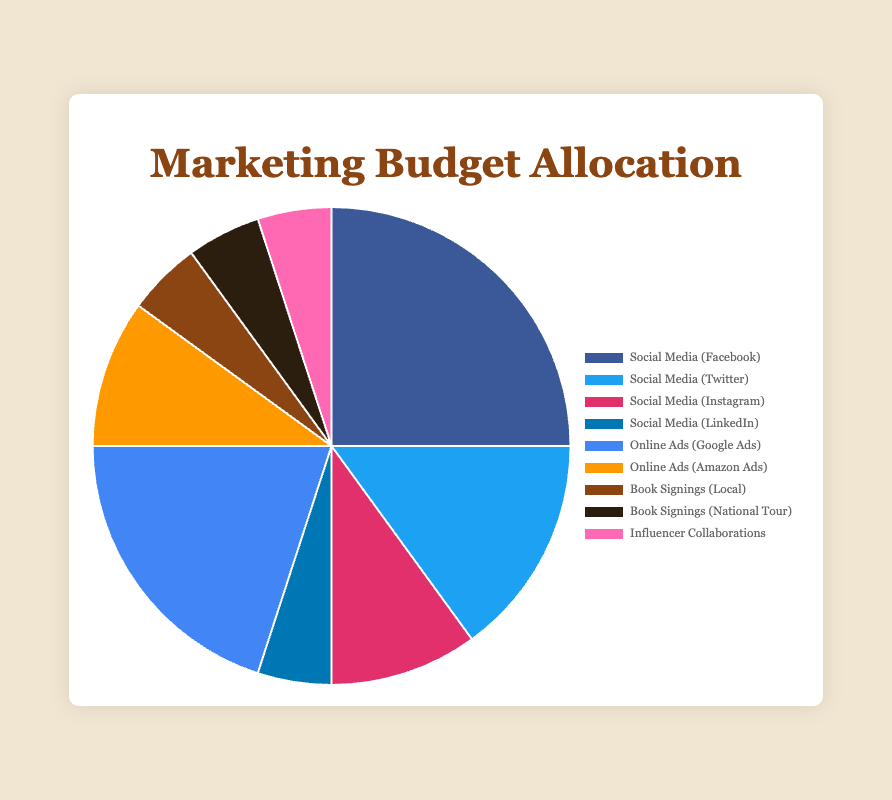Which promotional channel has the highest percentage allocation? To find the highest percentage allocation, compare all the percentages given in the marketing budget allocation. The highest percentage is 25%, which belongs to Social Media (Facebook).
Answer: Social Media (Facebook) What is the total percentage allocated to social media channels combined? To find the total percentage for social media channels, sum the percentages for Facebook, Twitter, Instagram, and LinkedIn: 25% + 15% + 10% + 5% = 55%.
Answer: 55% How does the allocation to online ads compare with the allocation to book signings? Add the percentages of the two categories within each group. For online ads (Google Ads + Amazon Ads): 20% + 10% = 30%. For book signings (Local + National Tour): 5% + 5% = 10%. Therefore, online ads (30%) have a higher allocation than book signings (10%).
Answer: Online ads have a higher allocation What percentage is allocated to channels other than social media? First, sum the percentages of all non-social media channels: Online Ads (20% + 10%) + Book Signings (5% + 5%) + Influencer Collaborations (5%) = 20% + 10% + 5% + 5% + 5% = 45%.
Answer: 45% Which channel has the lowest percentage allocation? Examine all the channels and identify the lowest percentage. Multiple channels have the lowest allocation of 5%: Social Media (LinkedIn), Book Signings (Local), Book Signings (National Tour), and Influencer Collaborations.
Answer: Social Media (LinkedIn), Book Signings (Local), Book Signings (National Tour), and Influencer Collaborations What is the difference in percentage allocation between Google Ads and Instagram? Subtract the percentage allocation of Instagram from Google Ads: 20% - 10% = 10%.
Answer: 10% What is the average percentage allocation for online ads? Find the average by adding the total percentage for Google Ads and Amazon Ads, then divide by the number of online ad channels. (20% + 10%) / 2 = 30% / 2 = 15%.
Answer: 15% Which color represents the allocation for Social Media (Facebook) in the pie chart? Identify the color used in the pie chart to represent Social Media (Facebook). According to the provided configuration, Social Media (Facebook) is represented by the first color in the dataset, which is blue.
Answer: Blue 